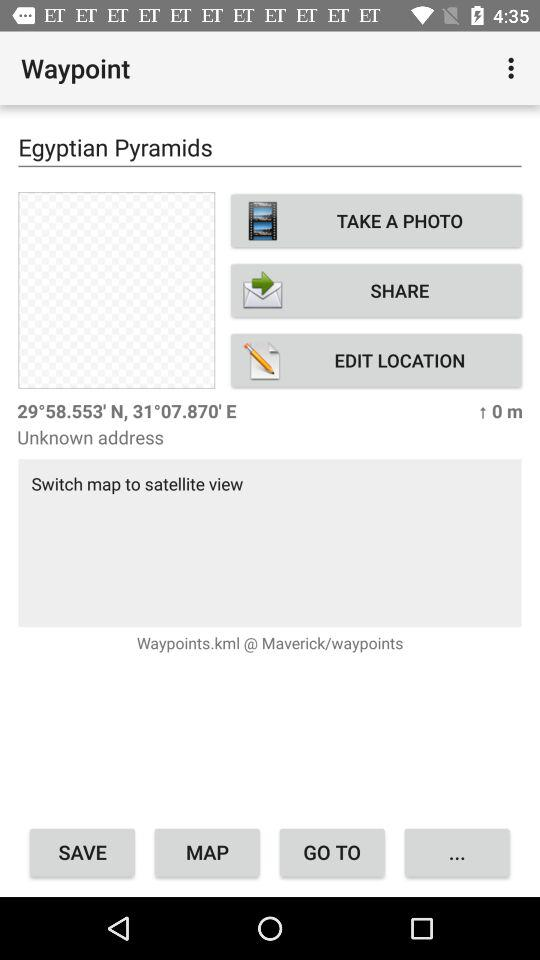What are the coordinates of the address? The coordinates of the address are 29° 58.553' N, 31° 07.870' E. 